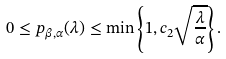Convert formula to latex. <formula><loc_0><loc_0><loc_500><loc_500>0 \leq p _ { \beta , \alpha } ( \lambda ) \leq \min \left \{ 1 , c _ { 2 } \sqrt { \frac { \lambda } { \alpha } } \right \} .</formula> 